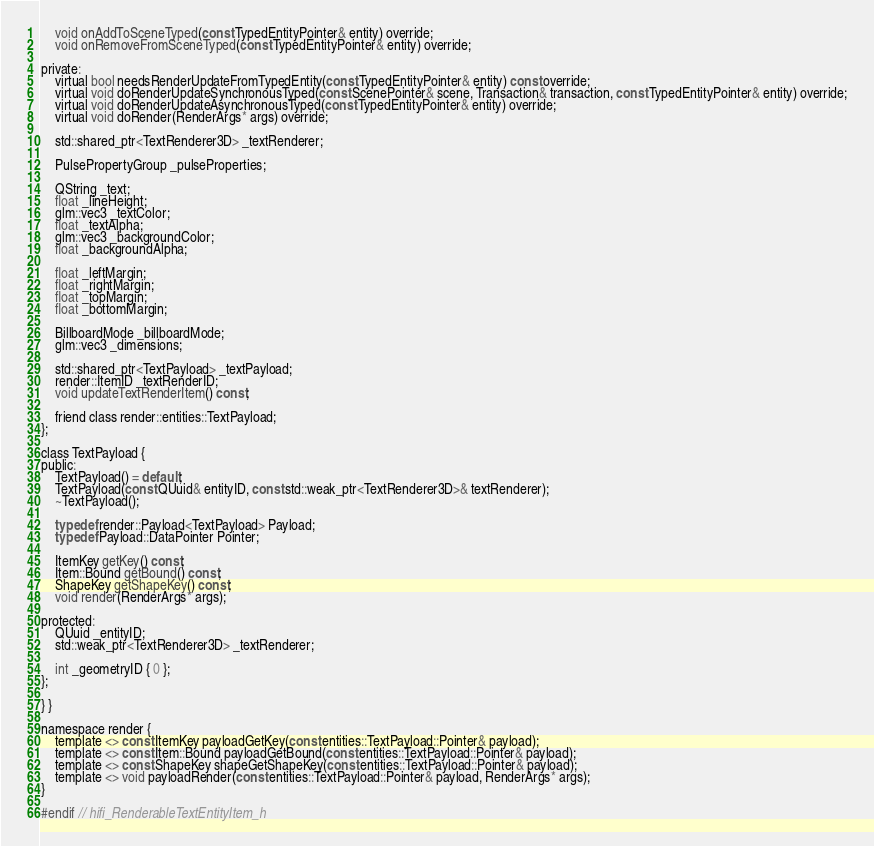Convert code to text. <code><loc_0><loc_0><loc_500><loc_500><_C_>    void onAddToSceneTyped(const TypedEntityPointer& entity) override;
    void onRemoveFromSceneTyped(const TypedEntityPointer& entity) override;

private:
    virtual bool needsRenderUpdateFromTypedEntity(const TypedEntityPointer& entity) const override;
    virtual void doRenderUpdateSynchronousTyped(const ScenePointer& scene, Transaction& transaction, const TypedEntityPointer& entity) override;
    virtual void doRenderUpdateAsynchronousTyped(const TypedEntityPointer& entity) override;
    virtual void doRender(RenderArgs* args) override;

    std::shared_ptr<TextRenderer3D> _textRenderer;

    PulsePropertyGroup _pulseProperties;

    QString _text;
    float _lineHeight;
    glm::vec3 _textColor;
    float _textAlpha;
    glm::vec3 _backgroundColor;
    float _backgroundAlpha;

    float _leftMargin;
    float _rightMargin;
    float _topMargin;
    float _bottomMargin;

    BillboardMode _billboardMode;
    glm::vec3 _dimensions;

    std::shared_ptr<TextPayload> _textPayload;
    render::ItemID _textRenderID;
    void updateTextRenderItem() const;

    friend class render::entities::TextPayload;
};

class TextPayload {
public:
    TextPayload() = default;
    TextPayload(const QUuid& entityID, const std::weak_ptr<TextRenderer3D>& textRenderer);
    ~TextPayload();

    typedef render::Payload<TextPayload> Payload;
    typedef Payload::DataPointer Pointer;

    ItemKey getKey() const;
    Item::Bound getBound() const;
    ShapeKey getShapeKey() const;
    void render(RenderArgs* args);

protected:
    QUuid _entityID;
    std::weak_ptr<TextRenderer3D> _textRenderer;

    int _geometryID { 0 };
};

} }

namespace render {
    template <> const ItemKey payloadGetKey(const entities::TextPayload::Pointer& payload);
    template <> const Item::Bound payloadGetBound(const entities::TextPayload::Pointer& payload);
    template <> const ShapeKey shapeGetShapeKey(const entities::TextPayload::Pointer& payload);
    template <> void payloadRender(const entities::TextPayload::Pointer& payload, RenderArgs* args);
}

#endif // hifi_RenderableTextEntityItem_h
</code> 